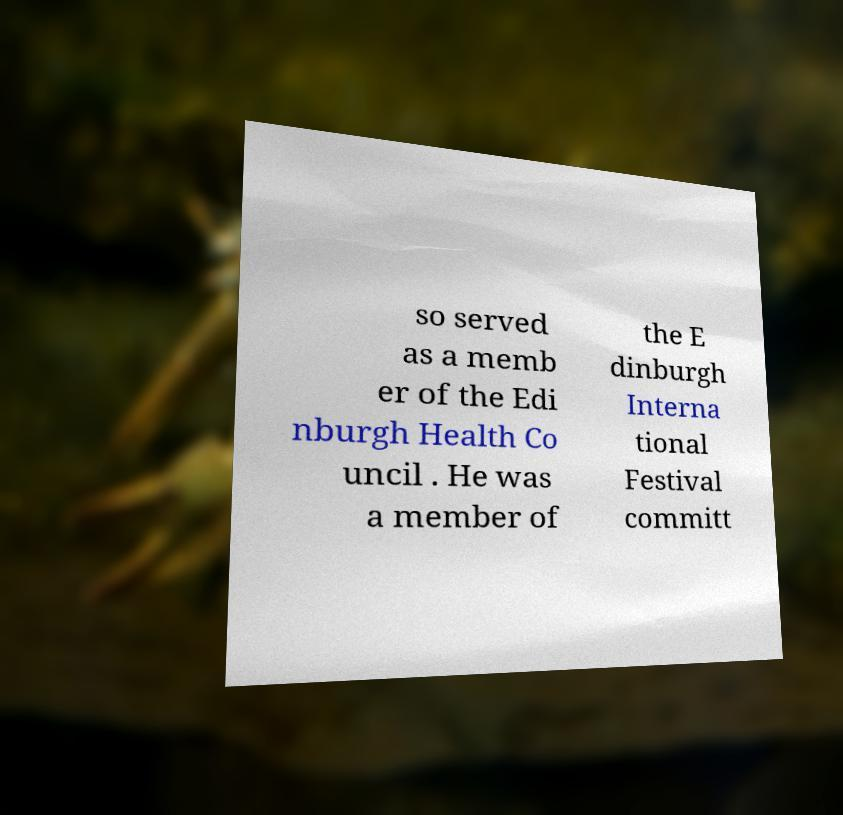Could you assist in decoding the text presented in this image and type it out clearly? so served as a memb er of the Edi nburgh Health Co uncil . He was a member of the E dinburgh Interna tional Festival committ 